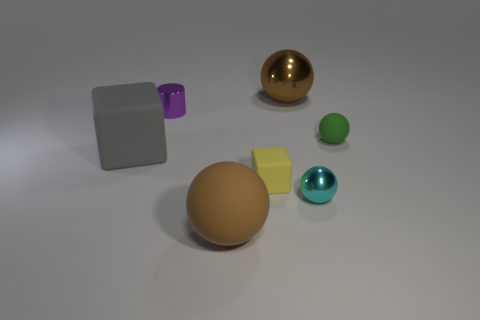Is the material of the big brown object behind the small metallic cylinder the same as the tiny purple object?
Give a very brief answer. Yes. How many other objects are the same material as the purple thing?
Your response must be concise. 2. What number of things are things that are to the right of the small cyan thing or small rubber things that are to the right of the yellow matte block?
Your response must be concise. 1. Do the large rubber object behind the tiny block and the tiny rubber object that is on the left side of the tiny cyan metal ball have the same shape?
Ensure brevity in your answer.  Yes. There is a green object that is the same size as the purple shiny object; what shape is it?
Offer a terse response. Sphere. How many matte things are small green spheres or red objects?
Keep it short and to the point. 1. Is the brown thing behind the green sphere made of the same material as the small thing that is in front of the small yellow rubber object?
Your response must be concise. Yes. There is a big object that is the same material as the tiny purple thing; what color is it?
Provide a short and direct response. Brown. Are there more spheres behind the tiny cyan metallic sphere than large balls that are in front of the gray matte cube?
Provide a succinct answer. Yes. Are there any large cyan matte objects?
Your response must be concise. No. 